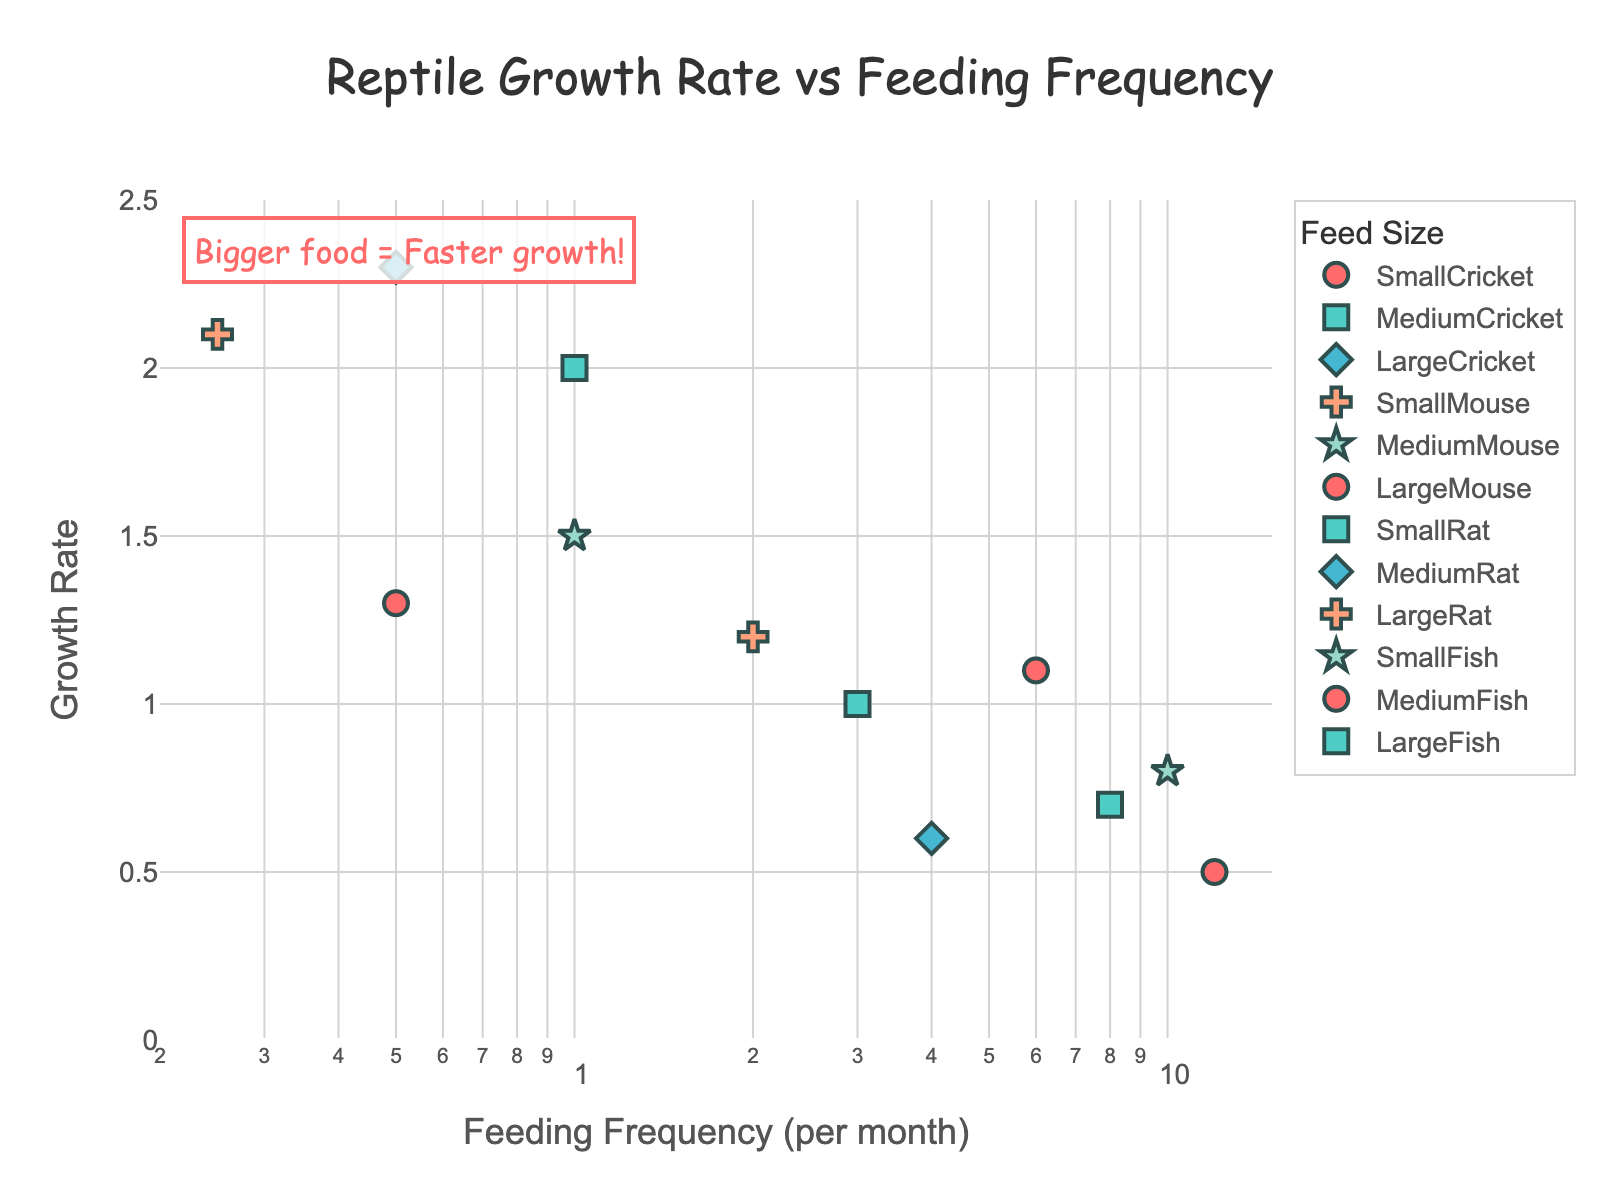What's the title of the figure? The title is located at the top center of the figure. It usually describes the main topic of the graph, "Reptile Growth Rate vs Feeding Frequency".
Answer: Reptile Growth Rate vs Feeding Frequency What type of scale is used for the x-axis? The x-axis represents 'Feeding Frequency (per month)' and it uses a logarithmic scale. This detail is listed under the x-axis title.
Answer: Logarithmic scale How many data points represent feedings with Small Mice? Observing the scatter plot marker colors and shapes, you notice the points are grouped by feed size. Small Mouse data points are two in number.
Answer: 2 Which food type shows the highest growth rate? Scan the y-axis for 'Growth Rate' and identify the highest point. The highest point, near 2.3, corresponds to Medium Rat.
Answer: Medium Rat How does feeding frequency relate to growth rate? Generally, as you look from left to right, higher frequency feedings (toward the left on the log scale) result in lower growth rates, except for larger prey like rats and mice. Shorter frequency with larger prey tends to result in faster growth, as noted by annotation.
Answer: Bigger food = Faster growth Which feed size has the most varied (spread out) growth rates? Check which feed has points scattered across a wider range on the y-axis. Small Crickets stretch from 0.5 to 0.8.
Answer: Small Crickets Which combination of feeding frequency and feed size results in approximately a growth rate of 1.5? Locate the y-axis value 1.5 and trace corresponding points across the x-axis. Medium Mouse fed once a month results in 1.5 growth rate.
Answer: Medium Mouse, once a month What is the minimum growth rate shown on the plot, and which food type does it correspond to? The smallest y-axis value (0.5) represents the minimum growth rate, which corresponds to Small Crickets fed 12 times a month.
Answer: 0.5, Small Crickets Among all the feed sizes, which one results in the highest frequency of feeding for a growth rate above 1? Focus on data points above 1 on the y-axis and their x-axis values. Small Fish fed 10 times per month for a growth rate above 1.
Answer: Small Fish, 10 times per month How many feed sizes show feeding frequencies less than 1 time per month on the plot? Identify points where the x-axis value is below 1. Large Mouse, Medium Rat, and Large Rat each have feed frequencies less than 1 per month.
Answer: 3 